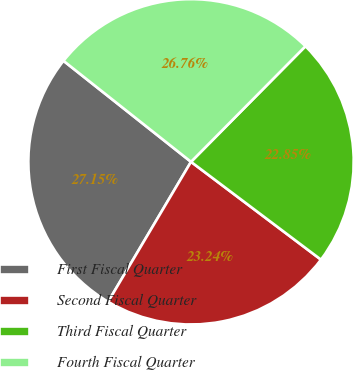Convert chart. <chart><loc_0><loc_0><loc_500><loc_500><pie_chart><fcel>First Fiscal Quarter<fcel>Second Fiscal Quarter<fcel>Third Fiscal Quarter<fcel>Fourth Fiscal Quarter<nl><fcel>27.15%<fcel>23.24%<fcel>22.85%<fcel>26.76%<nl></chart> 